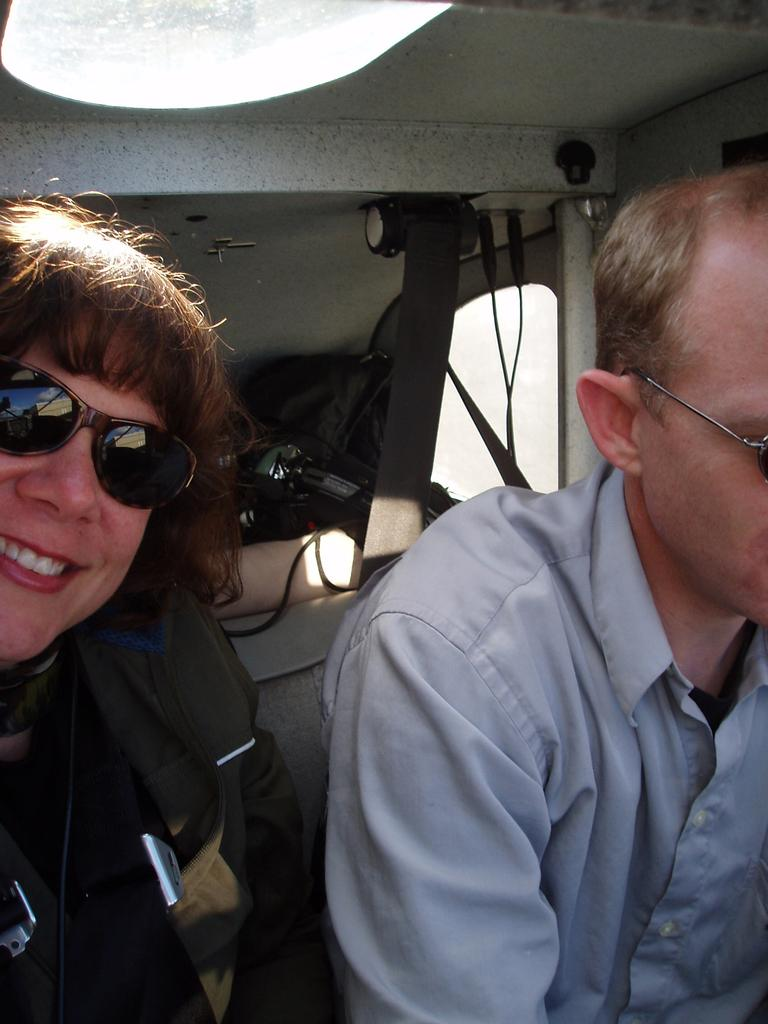How many people are in the image? There are persons in the image, but the exact number is not specified. What are the persons wearing in the image? The persons are wearing clothes and sunglasses in the image. What can be seen on the right side of the image? There is a window on the right side of the image. What type of rail is visible in the image? There is no rail present in the image. What is the persons' reaction to the loss in the image? There is no indication of any loss or reaction to it in the image. 